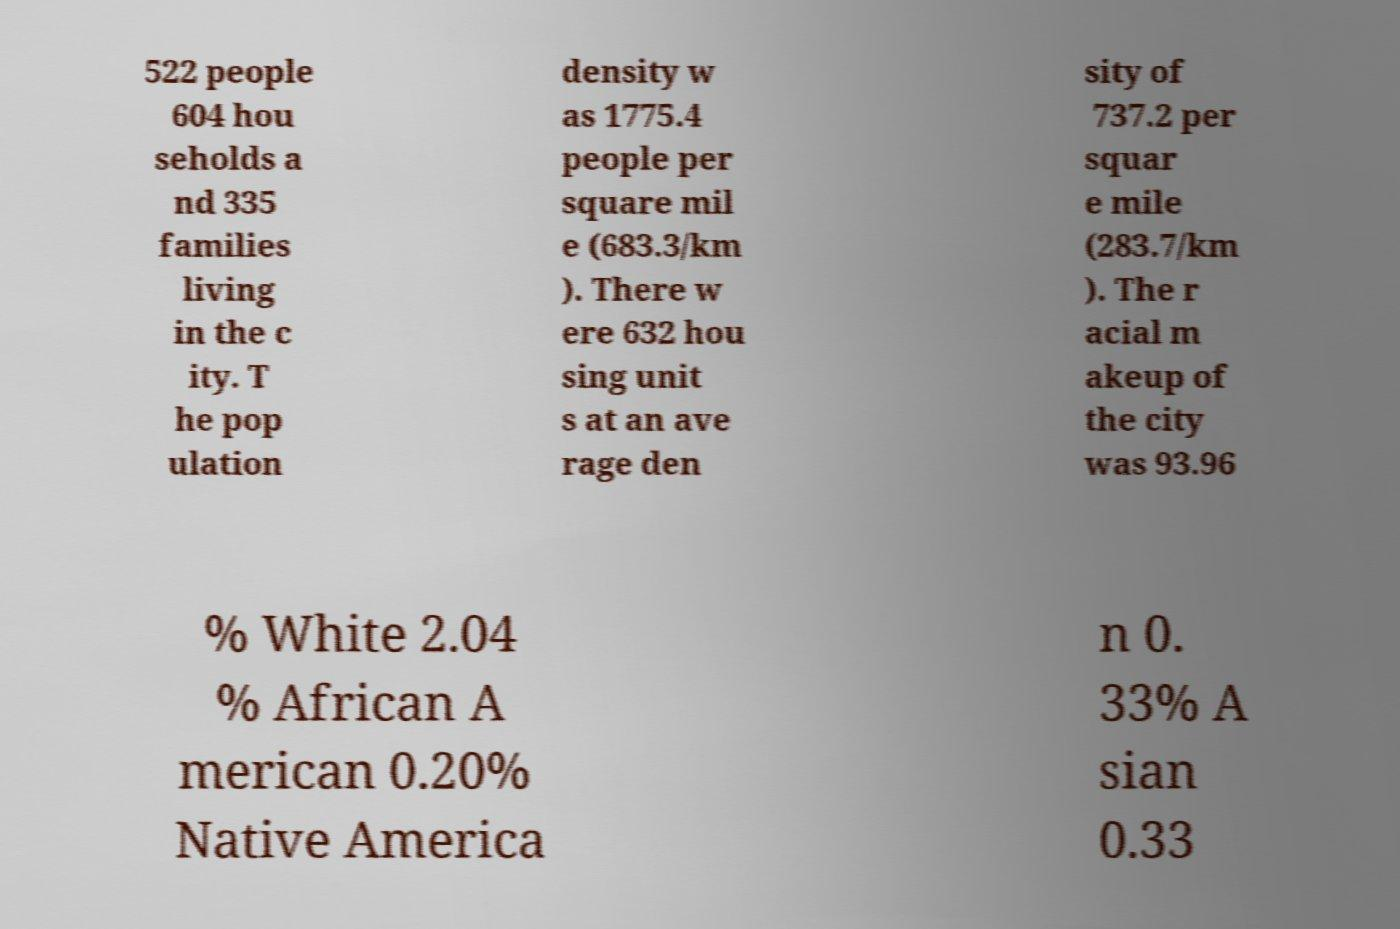For documentation purposes, I need the text within this image transcribed. Could you provide that? 522 people 604 hou seholds a nd 335 families living in the c ity. T he pop ulation density w as 1775.4 people per square mil e (683.3/km ). There w ere 632 hou sing unit s at an ave rage den sity of 737.2 per squar e mile (283.7/km ). The r acial m akeup of the city was 93.96 % White 2.04 % African A merican 0.20% Native America n 0. 33% A sian 0.33 